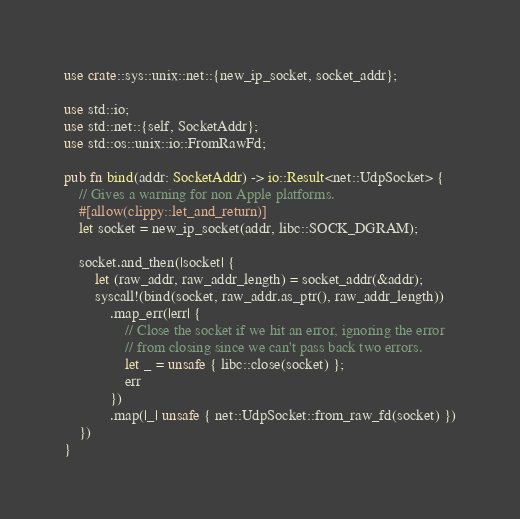<code> <loc_0><loc_0><loc_500><loc_500><_Rust_>use crate::sys::unix::net::{new_ip_socket, socket_addr};

use std::io;
use std::net::{self, SocketAddr};
use std::os::unix::io::FromRawFd;

pub fn bind(addr: SocketAddr) -> io::Result<net::UdpSocket> {
    // Gives a warning for non Apple platforms.
    #[allow(clippy::let_and_return)]
    let socket = new_ip_socket(addr, libc::SOCK_DGRAM);

    socket.and_then(|socket| {
        let (raw_addr, raw_addr_length) = socket_addr(&addr);
        syscall!(bind(socket, raw_addr.as_ptr(), raw_addr_length))
            .map_err(|err| {
                // Close the socket if we hit an error, ignoring the error
                // from closing since we can't pass back two errors.
                let _ = unsafe { libc::close(socket) };
                err
            })
            .map(|_| unsafe { net::UdpSocket::from_raw_fd(socket) })
    })
}
</code> 